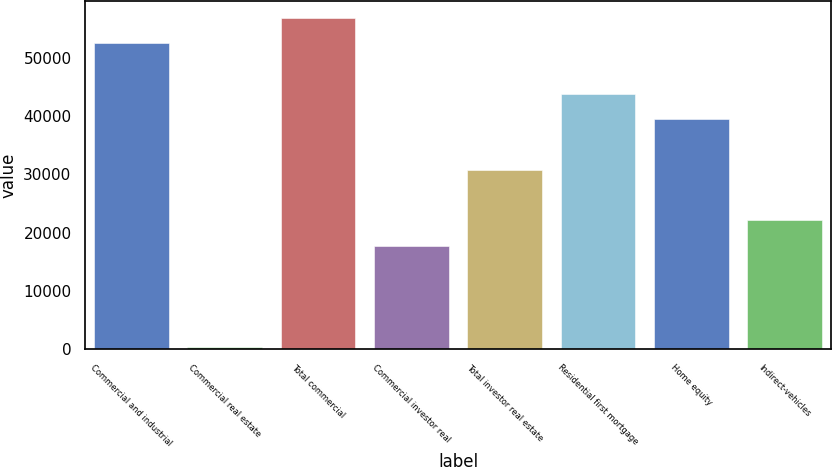Convert chart. <chart><loc_0><loc_0><loc_500><loc_500><bar_chart><fcel>Commercial and industrial<fcel>Commercial real estate<fcel>Total commercial<fcel>Commercial investor real<fcel>Total investor real estate<fcel>Residential first mortgage<fcel>Home equity<fcel>Indirect-vehicles<nl><fcel>52453.8<fcel>423<fcel>56789.7<fcel>17766.6<fcel>30774.3<fcel>43782<fcel>39446.1<fcel>22102.5<nl></chart> 